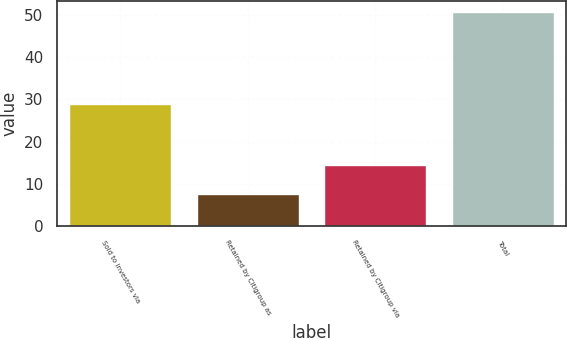Convert chart. <chart><loc_0><loc_0><loc_500><loc_500><bar_chart><fcel>Sold to investors via<fcel>Retained by Citigroup as<fcel>Retained by Citigroup via<fcel>Total<nl><fcel>28.8<fcel>7.6<fcel>14.4<fcel>50.8<nl></chart> 